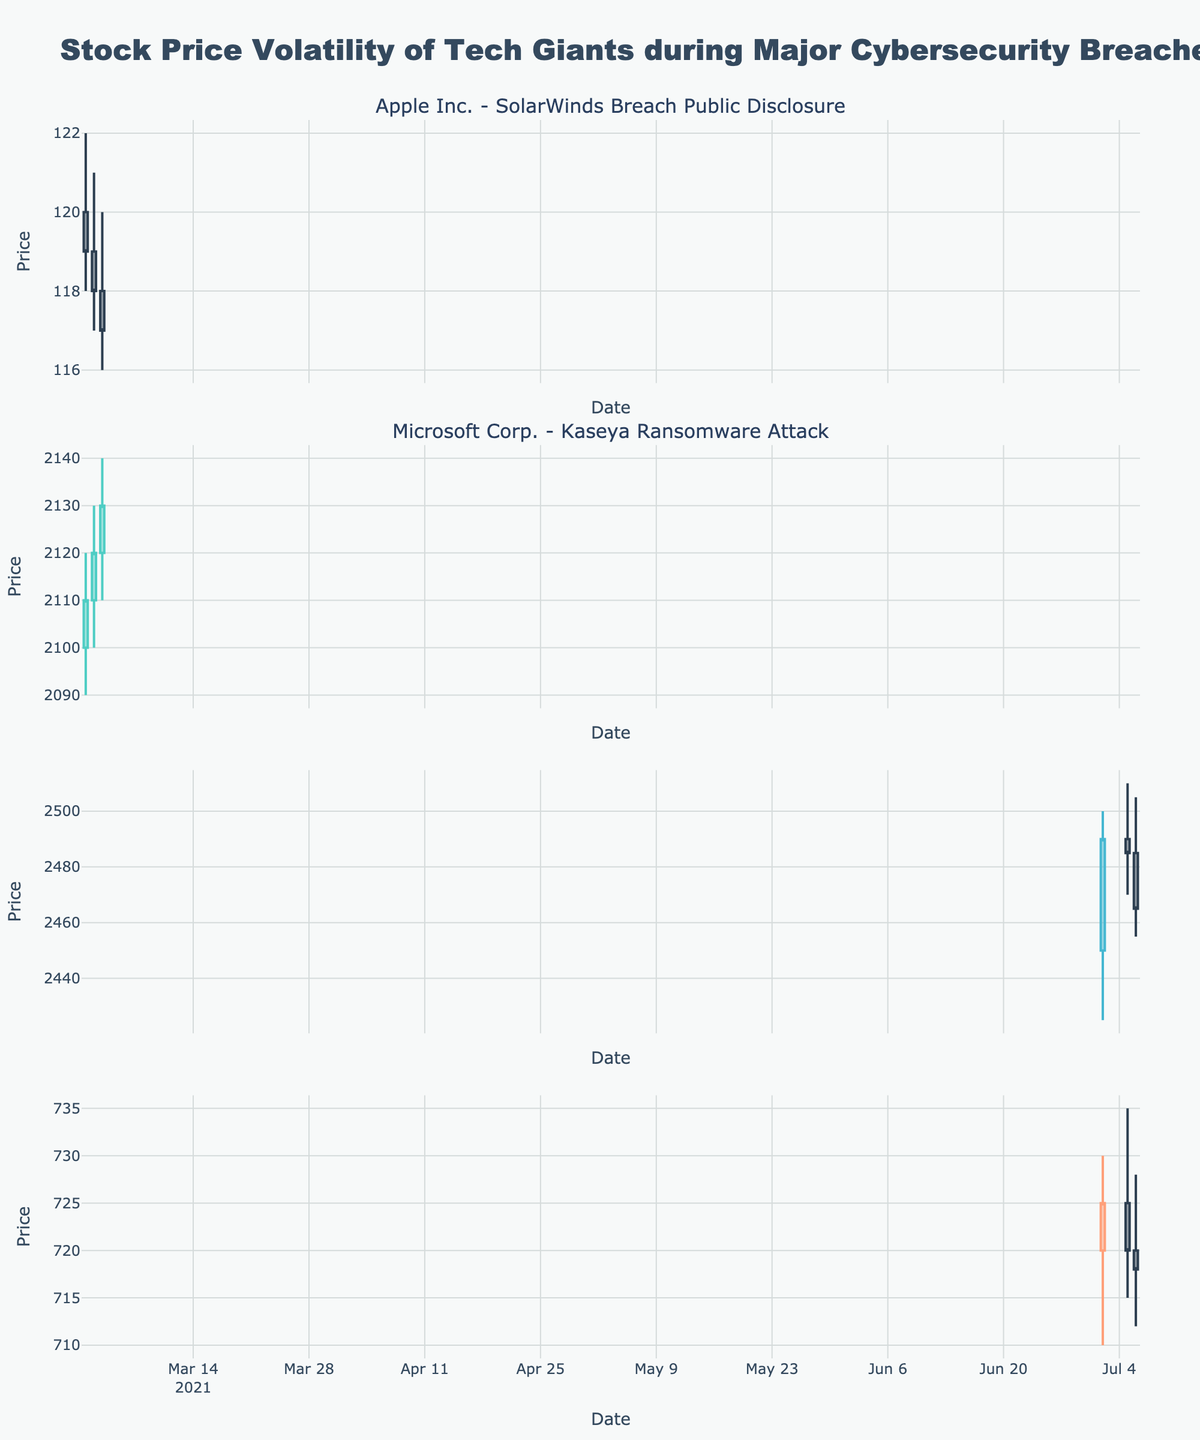What's the title of the figure? The title is located at the top center of the figure and summarizes the content of the plot.
Answer: Stock Price Volatility of Tech Giants during Major Cybersecurity Breaches How many subplots are there in the figure? The figure has one subplot for each unique company and event pair, which can be counted visually by noting the individual candlestick plots.
Answer: 4 Which company experienced a larger stock price drop on March 2, 2021, Apple Inc. or Microsoft Corp.? To determine this, compare the difference between the Open and Close prices for both companies on March 2, 2021. Apple Inc.'s drop: (119 - 118) = $1. Microsoft Corp.'s drop: (2110 - 2120) = -$10. Therefore, Apple Inc. experienced a $1 drop, while Microsoft Corp. experienced a $10 increase.
Answer: Apple Inc What was the highest stock price recorded for Amazon.com Inc. during the Kaseya Ransomware Attack? Identify the peak value from the High prices of Amazon.com Inc. during the event dates. Visually find the highest peak in the candlestick plots for Amazon.com Inc. (July 2 - July 6, 2021).
Answer: 2500 Was the overall trend for Facebook Inc. stock positive or negative during the Kaseya Ransomware Attack? Examine the candlestick plot for Facebook Inc. to see if the overall closing prices from the start to the end of the event period (July 2 - July 6, 2021) show an upward or downward trend. Starting at 725 on July 2 and ending at 718 on July 6, the trend is downward.
Answer: Negative Compare the stock price volatility for Apple Inc. and Microsoft Corp. during the SolarWinds Breach Public Disclosure. Which company shows higher volatility? Volatility can be observed by assessing the range (High - Low) for the companies during the event dates. Apple Inc.: Max range = 4 (122 - 118). Microsoft Corp.: Max range = 3 (2140 - 2110). Apple Inc. shows higher volatility.
Answer: Apple Inc What is the average closing price for Amazon.com Inc. during the Kaseya Ransomware Attack? Add the Closing prices for each day of Amazon.com Inc. during the event dates and then divide by the number of days. Calculation: (2490 + 2485 + 2465) / 3 = 7440 / 3 = 2480.
Answer: 2480 On which date did Facebook Inc. (Meta) have the highest trading volume during the Kaseya Ransomware Attack? Check the Volume values for Facebook Inc. on each event date and find the maximum value. The highest volume recorded is on July 5, with 550,000 shares traded.
Answer: July 5, 2021 